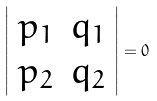Convert formula to latex. <formula><loc_0><loc_0><loc_500><loc_500>\left | \begin{array} { c c } p _ { 1 } & q _ { 1 } \\ p _ { 2 } & q _ { 2 } \\ \end{array} \right | = 0</formula> 